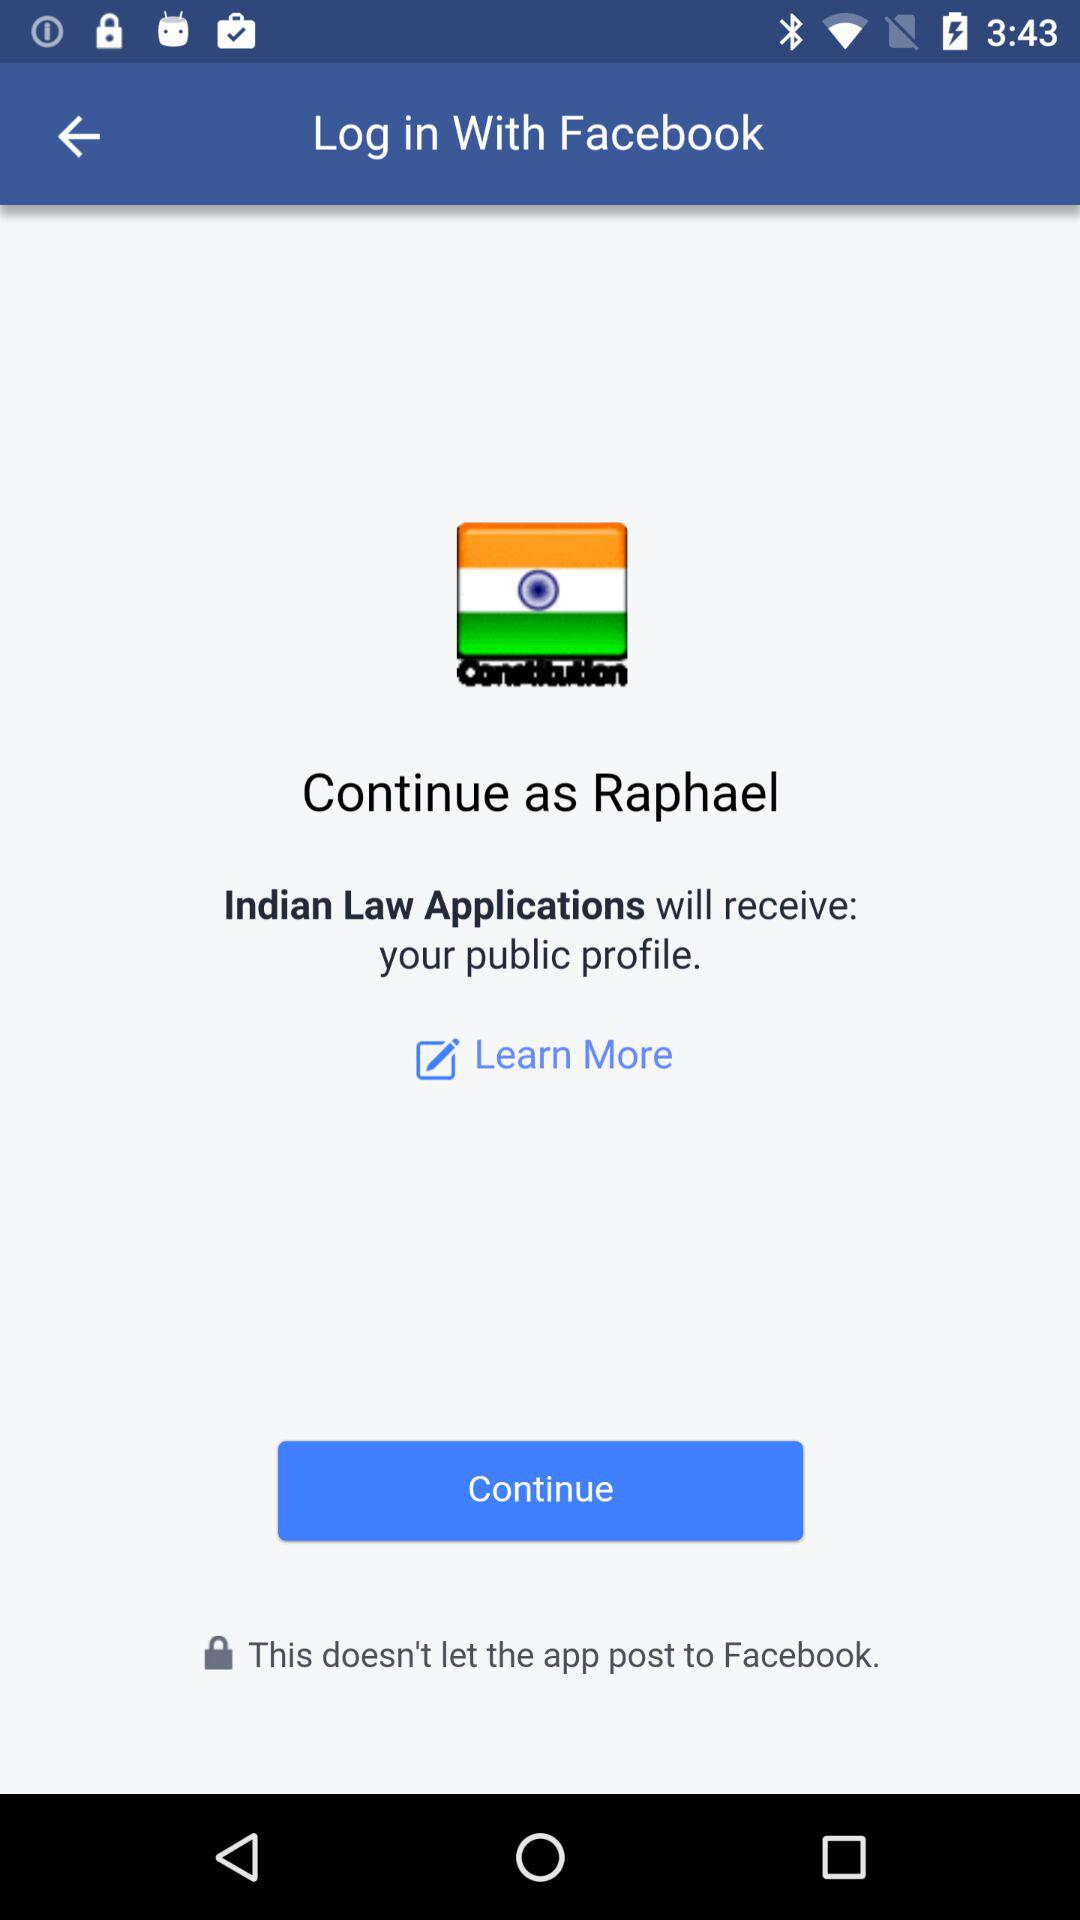What application will receive your public profile? The application "Indian Law Applications" will receive your public profile. 